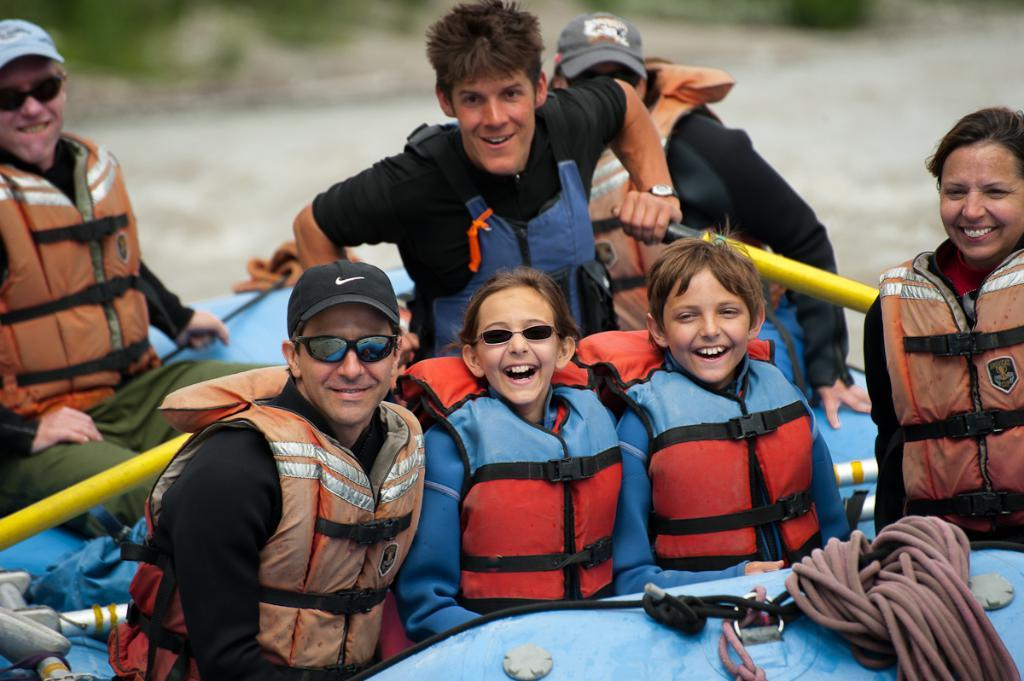Who is present in the image? There are people in the image. What are the people wearing? The people are wearing safety jackets. What are the people sitting in? The people are sitting in a raft. What can be seen in the background of the image? There is water visible in the background of the image. What type of acoustics can be heard coming from the tank in the image? There is no tank present in the image, so it's not possible to determine what, if any, acoustics might be heard. 